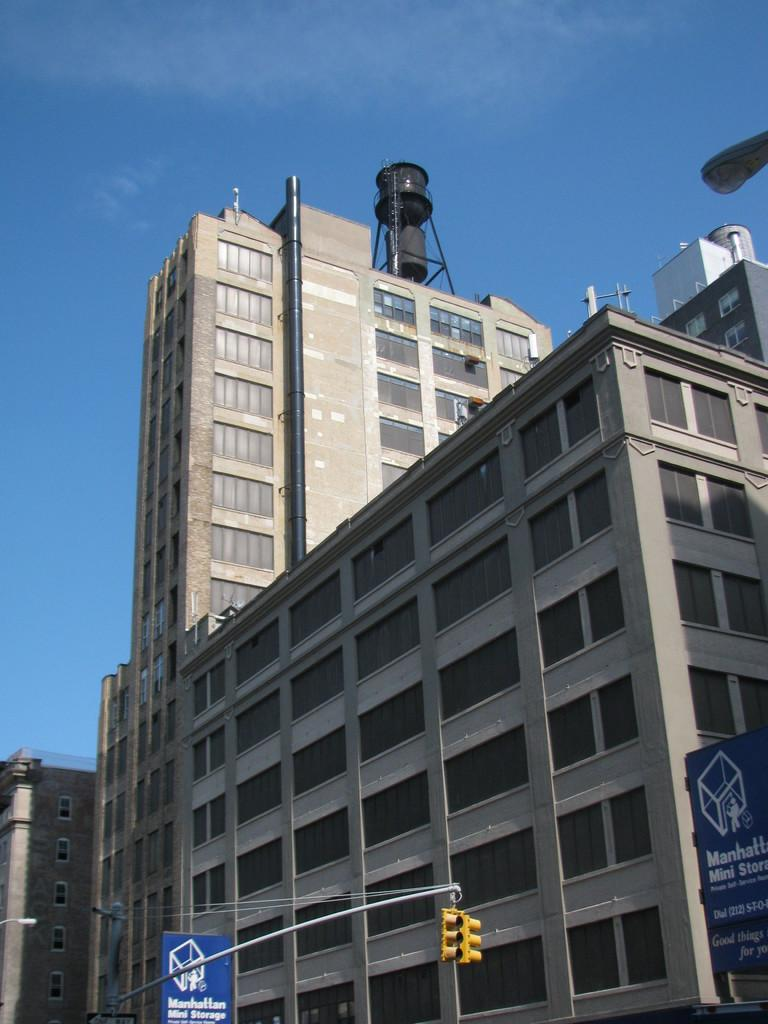What type of structure can be seen in the image? There is a building in the image. What part of the natural environment is visible in the image? The sky is visible in the image. Are there any fairies flying around the building in the image? There is no indication of fairies in the image; only the building and sky are visible. Can you see any icicles hanging from the building in the image? There is no mention of icicles in the image; only the building and sky are visible. 